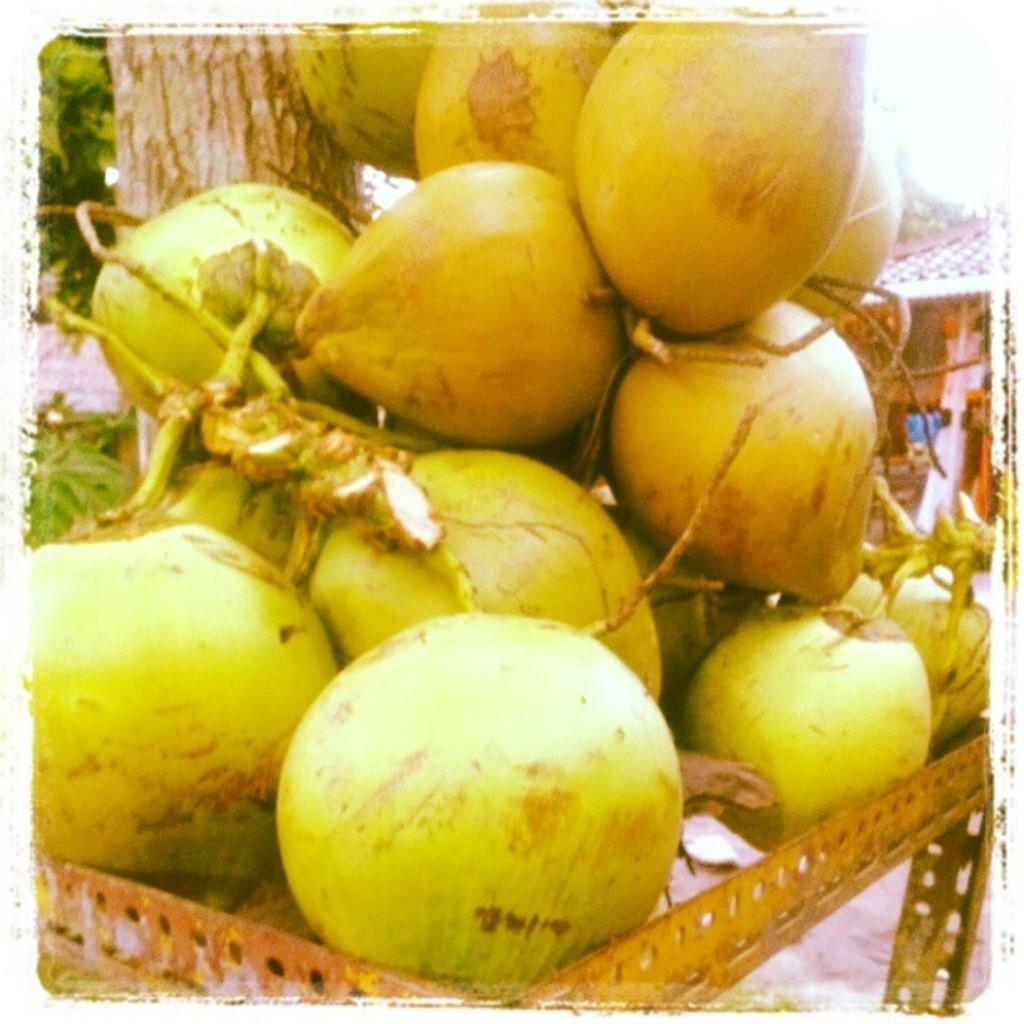What is the main subject of the image? The main subject of the image is a bunch of coconuts. Can you describe the setting of the image? There is a tree in the image. What type of train can be seen passing by the coconuts in the image? There is no train present in the image; it only features a bunch of coconuts and a tree. What tool is being used to dig near the coconuts in the image? There is no tool or digging activity depicted in the image; it only features a bunch of coconuts and a tree. 